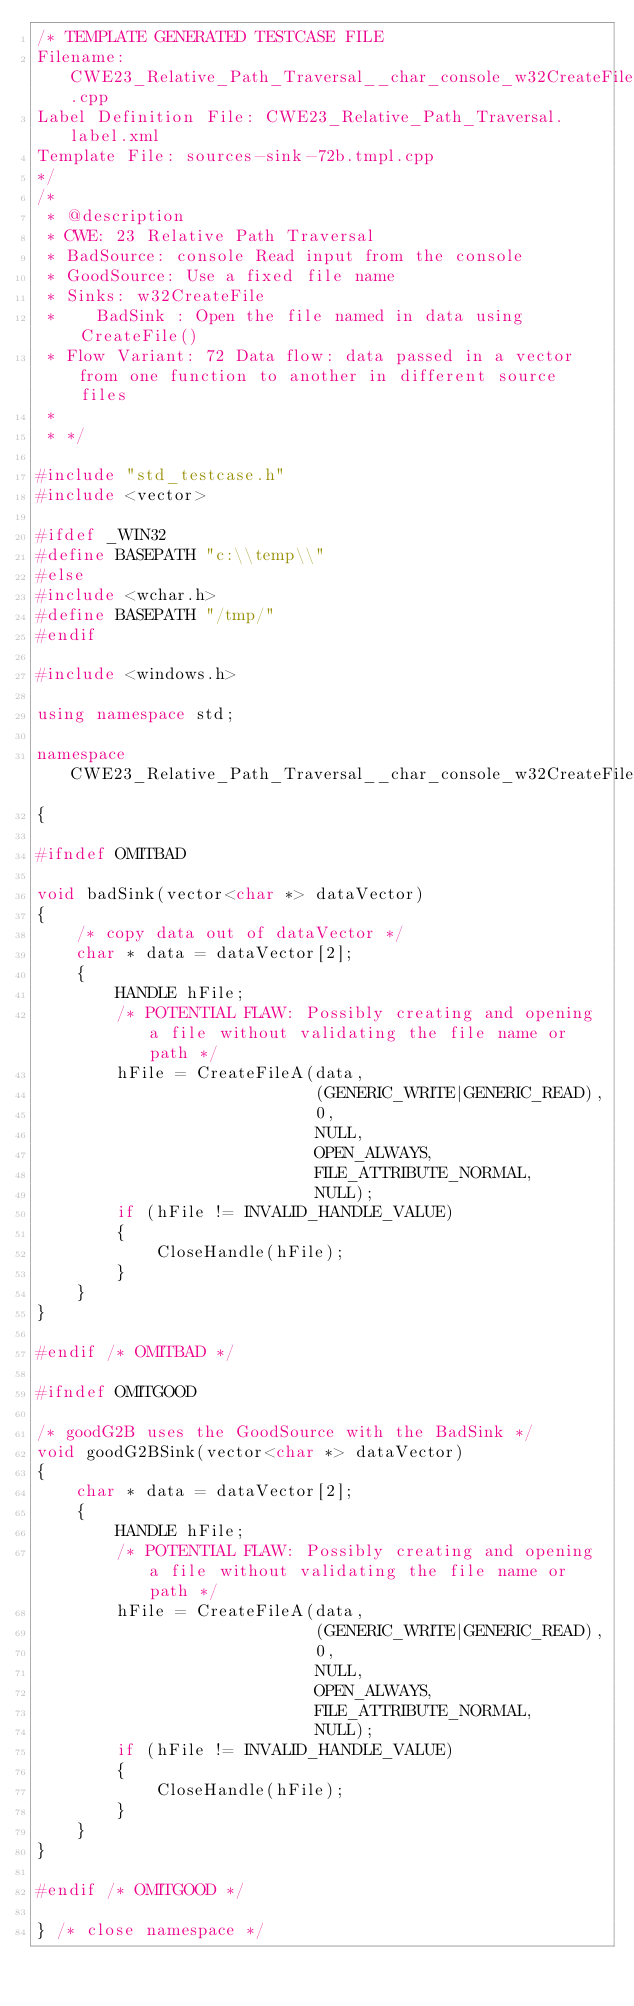<code> <loc_0><loc_0><loc_500><loc_500><_C++_>/* TEMPLATE GENERATED TESTCASE FILE
Filename: CWE23_Relative_Path_Traversal__char_console_w32CreateFile_72b.cpp
Label Definition File: CWE23_Relative_Path_Traversal.label.xml
Template File: sources-sink-72b.tmpl.cpp
*/
/*
 * @description
 * CWE: 23 Relative Path Traversal
 * BadSource: console Read input from the console
 * GoodSource: Use a fixed file name
 * Sinks: w32CreateFile
 *    BadSink : Open the file named in data using CreateFile()
 * Flow Variant: 72 Data flow: data passed in a vector from one function to another in different source files
 *
 * */

#include "std_testcase.h"
#include <vector>

#ifdef _WIN32
#define BASEPATH "c:\\temp\\"
#else
#include <wchar.h>
#define BASEPATH "/tmp/"
#endif

#include <windows.h>

using namespace std;

namespace CWE23_Relative_Path_Traversal__char_console_w32CreateFile_72
{

#ifndef OMITBAD

void badSink(vector<char *> dataVector)
{
    /* copy data out of dataVector */
    char * data = dataVector[2];
    {
        HANDLE hFile;
        /* POTENTIAL FLAW: Possibly creating and opening a file without validating the file name or path */
        hFile = CreateFileA(data,
                            (GENERIC_WRITE|GENERIC_READ),
                            0,
                            NULL,
                            OPEN_ALWAYS,
                            FILE_ATTRIBUTE_NORMAL,
                            NULL);
        if (hFile != INVALID_HANDLE_VALUE)
        {
            CloseHandle(hFile);
        }
    }
}

#endif /* OMITBAD */

#ifndef OMITGOOD

/* goodG2B uses the GoodSource with the BadSink */
void goodG2BSink(vector<char *> dataVector)
{
    char * data = dataVector[2];
    {
        HANDLE hFile;
        /* POTENTIAL FLAW: Possibly creating and opening a file without validating the file name or path */
        hFile = CreateFileA(data,
                            (GENERIC_WRITE|GENERIC_READ),
                            0,
                            NULL,
                            OPEN_ALWAYS,
                            FILE_ATTRIBUTE_NORMAL,
                            NULL);
        if (hFile != INVALID_HANDLE_VALUE)
        {
            CloseHandle(hFile);
        }
    }
}

#endif /* OMITGOOD */

} /* close namespace */
</code> 